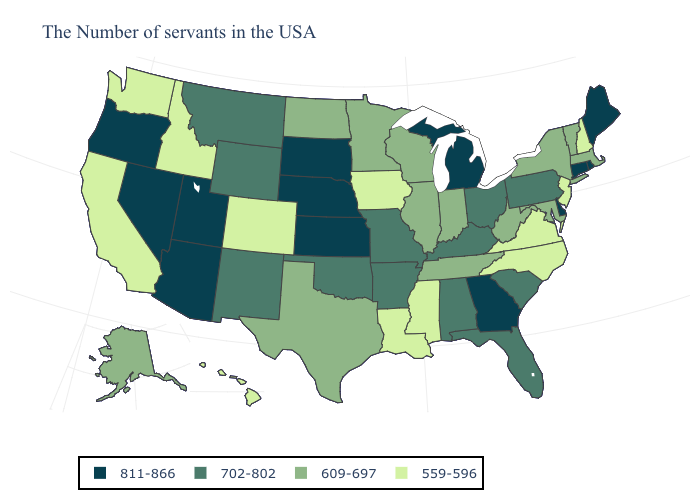Does Kansas have the highest value in the MidWest?
Keep it brief. Yes. Name the states that have a value in the range 702-802?
Quick response, please. Pennsylvania, South Carolina, Ohio, Florida, Kentucky, Alabama, Missouri, Arkansas, Oklahoma, Wyoming, New Mexico, Montana. Which states hav the highest value in the Northeast?
Be succinct. Maine, Rhode Island, Connecticut. What is the lowest value in states that border Maryland?
Keep it brief. 559-596. Name the states that have a value in the range 559-596?
Answer briefly. New Hampshire, New Jersey, Virginia, North Carolina, Mississippi, Louisiana, Iowa, Colorado, Idaho, California, Washington, Hawaii. Does Maryland have a lower value than Kentucky?
Short answer required. Yes. How many symbols are there in the legend?
Keep it brief. 4. Does Connecticut have the lowest value in the USA?
Answer briefly. No. Name the states that have a value in the range 702-802?
Be succinct. Pennsylvania, South Carolina, Ohio, Florida, Kentucky, Alabama, Missouri, Arkansas, Oklahoma, Wyoming, New Mexico, Montana. What is the lowest value in the South?
Concise answer only. 559-596. What is the value of Massachusetts?
Answer briefly. 609-697. Is the legend a continuous bar?
Concise answer only. No. Among the states that border New Hampshire , does Massachusetts have the lowest value?
Quick response, please. Yes. Does the first symbol in the legend represent the smallest category?
Answer briefly. No. 